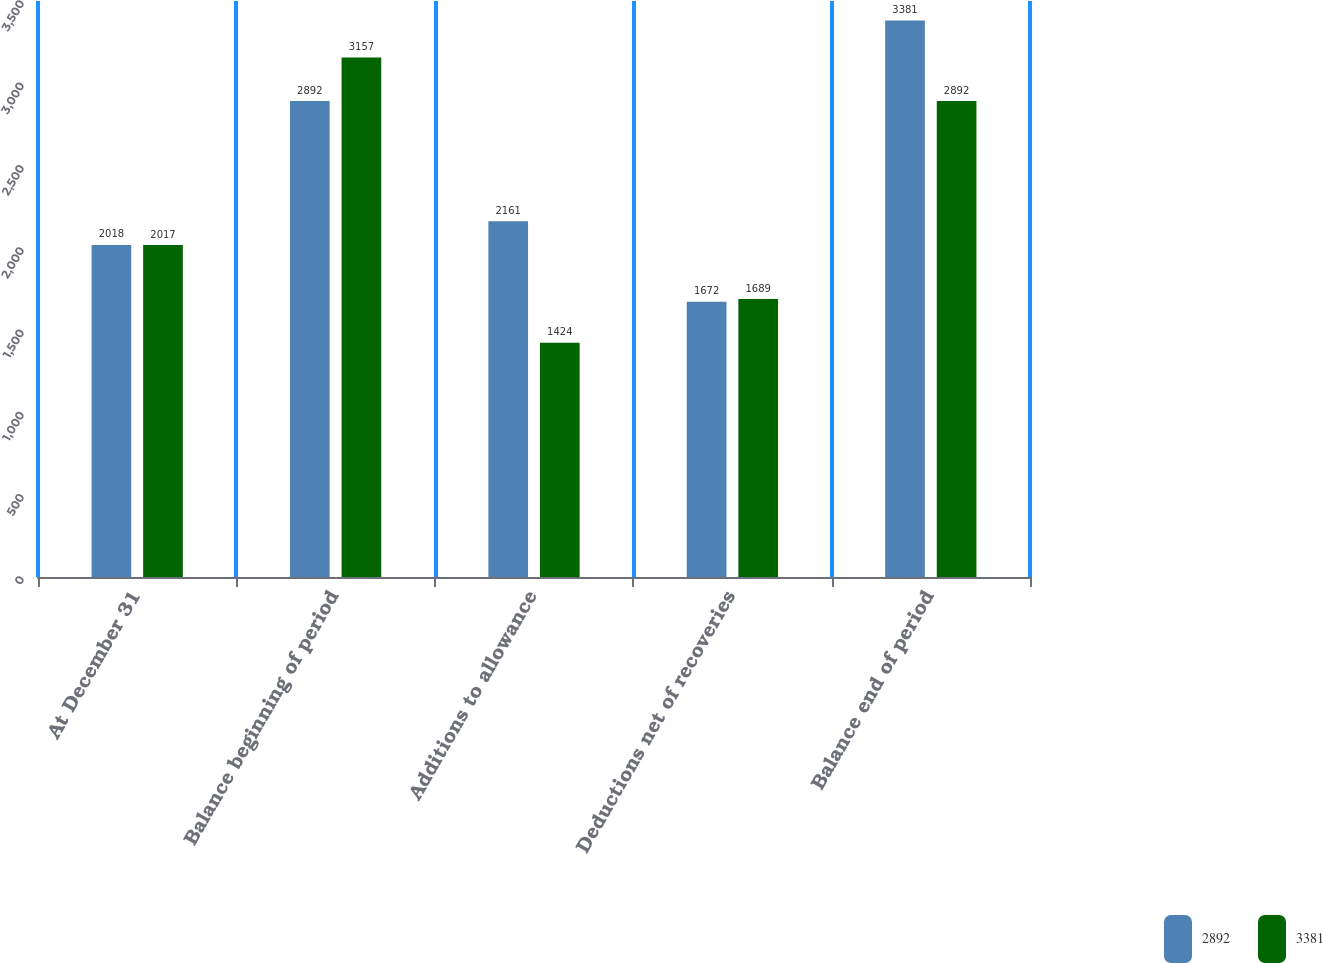Convert chart to OTSL. <chart><loc_0><loc_0><loc_500><loc_500><stacked_bar_chart><ecel><fcel>At December 31<fcel>Balance beginning of period<fcel>Additions to allowance<fcel>Deductions net of recoveries<fcel>Balance end of period<nl><fcel>2892<fcel>2018<fcel>2892<fcel>2161<fcel>1672<fcel>3381<nl><fcel>3381<fcel>2017<fcel>3157<fcel>1424<fcel>1689<fcel>2892<nl></chart> 